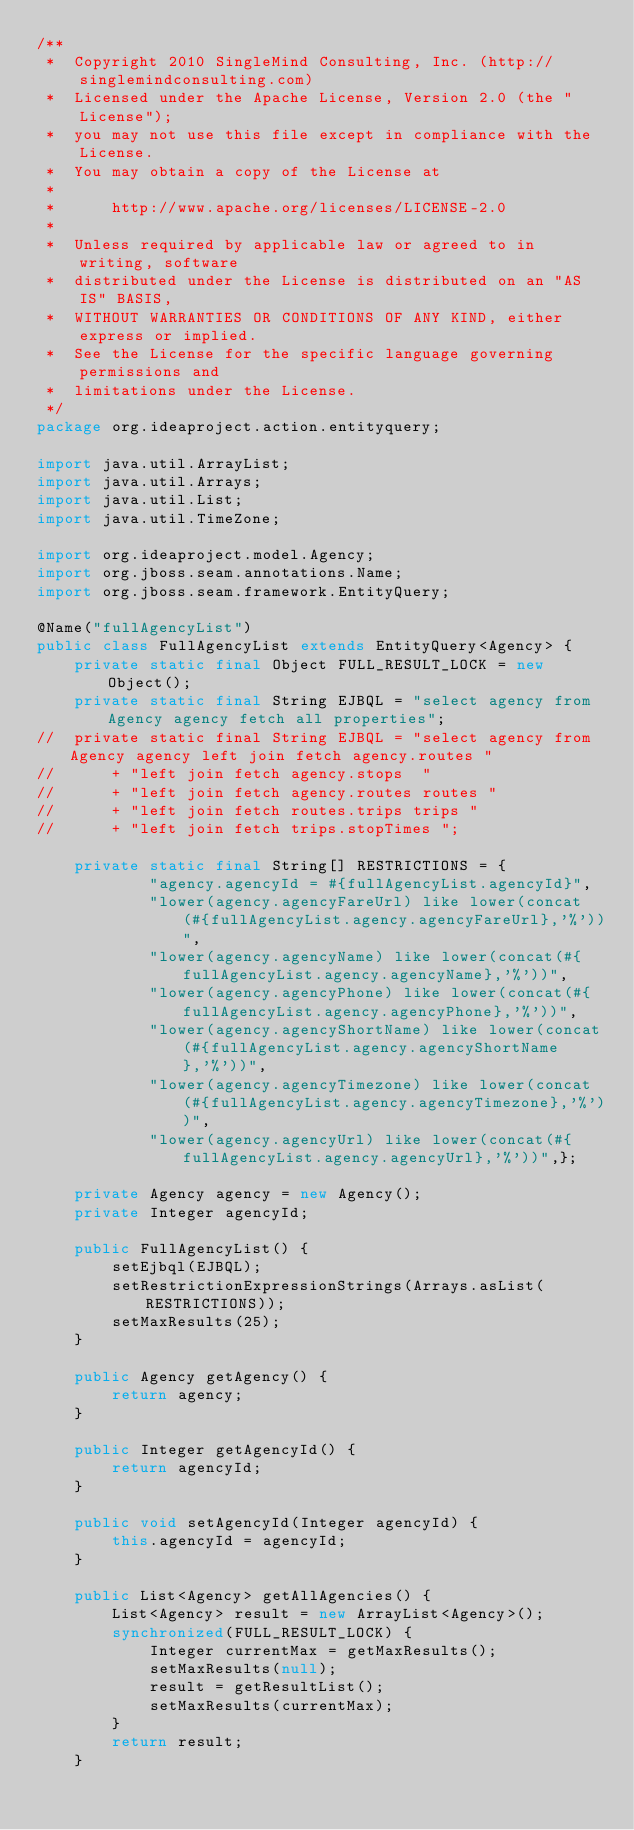<code> <loc_0><loc_0><loc_500><loc_500><_Java_>/**
 *  Copyright 2010 SingleMind Consulting, Inc. (http://singlemindconsulting.com)
 *  Licensed under the Apache License, Version 2.0 (the "License");
 *  you may not use this file except in compliance with the License.
 *  You may obtain a copy of the License at
 *  
 *  	http://www.apache.org/licenses/LICENSE-2.0
 *  
 *  Unless required by applicable law or agreed to in writing, software
 *  distributed under the License is distributed on an "AS IS" BASIS,
 *  WITHOUT WARRANTIES OR CONDITIONS OF ANY KIND, either express or implied.
 *  See the License for the specific language governing permissions and
 *  limitations under the License. 
 */
package org.ideaproject.action.entityquery;

import java.util.ArrayList;
import java.util.Arrays;
import java.util.List;
import java.util.TimeZone;

import org.ideaproject.model.Agency;
import org.jboss.seam.annotations.Name;
import org.jboss.seam.framework.EntityQuery;

@Name("fullAgencyList")
public class FullAgencyList extends EntityQuery<Agency> {
	private static final Object FULL_RESULT_LOCK = new Object();
	private static final String EJBQL = "select agency from Agency agency fetch all properties";
//	private static final String EJBQL = "select agency from Agency agency left join fetch agency.routes "
//		+ "left join fetch agency.stops  "
//		+ "left join fetch agency.routes routes "
//		+ "left join fetch routes.trips trips "
//		+ "left join fetch trips.stopTimes ";

	private static final String[] RESTRICTIONS = {
			"agency.agencyId = #{fullAgencyList.agencyId}",
			"lower(agency.agencyFareUrl) like lower(concat(#{fullAgencyList.agency.agencyFareUrl},'%'))",
			"lower(agency.agencyName) like lower(concat(#{fullAgencyList.agency.agencyName},'%'))",
			"lower(agency.agencyPhone) like lower(concat(#{fullAgencyList.agency.agencyPhone},'%'))",
			"lower(agency.agencyShortName) like lower(concat(#{fullAgencyList.agency.agencyShortName},'%'))",
			"lower(agency.agencyTimezone) like lower(concat(#{fullAgencyList.agency.agencyTimezone},'%'))",
			"lower(agency.agencyUrl) like lower(concat(#{fullAgencyList.agency.agencyUrl},'%'))",};

	private Agency agency = new Agency();
	private Integer agencyId;

	public FullAgencyList() {
		setEjbql(EJBQL);
		setRestrictionExpressionStrings(Arrays.asList(RESTRICTIONS));
		setMaxResults(25);
	}

	public Agency getAgency() {
		return agency;
	}

	public Integer getAgencyId() {
		return agencyId;
	}

	public void setAgencyId(Integer agencyId) {
		this.agencyId = agencyId;
	}

	public List<Agency> getAllAgencies() {
		List<Agency> result = new ArrayList<Agency>();
		synchronized(FULL_RESULT_LOCK) {
			Integer currentMax = getMaxResults();
			setMaxResults(null);
			result = getResultList();
			setMaxResults(currentMax);
		}
		return result;
	}
</code> 